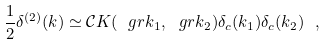Convert formula to latex. <formula><loc_0><loc_0><loc_500><loc_500>\frac { 1 } { 2 } \delta ^ { ( 2 ) } ( k ) \simeq \mathcal { C } K ( \ g r { k } _ { 1 } , \ g r { k } _ { 2 } ) \delta _ { c } ( k _ { 1 } ) \delta _ { c } ( k _ { 2 } ) \ ,</formula> 